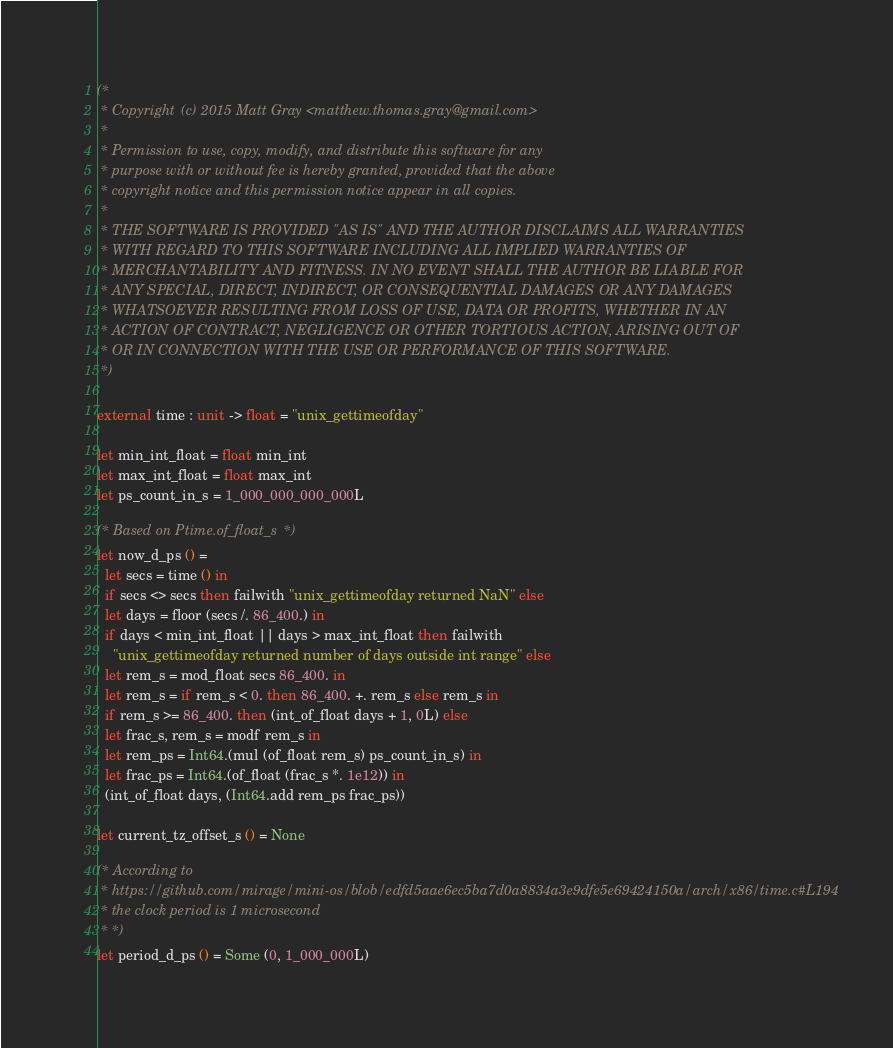<code> <loc_0><loc_0><loc_500><loc_500><_OCaml_>(*
 * Copyright (c) 2015 Matt Gray <matthew.thomas.gray@gmail.com>
 *
 * Permission to use, copy, modify, and distribute this software for any
 * purpose with or without fee is hereby granted, provided that the above
 * copyright notice and this permission notice appear in all copies.
 *
 * THE SOFTWARE IS PROVIDED "AS IS" AND THE AUTHOR DISCLAIMS ALL WARRANTIES
 * WITH REGARD TO THIS SOFTWARE INCLUDING ALL IMPLIED WARRANTIES OF
 * MERCHANTABILITY AND FITNESS. IN NO EVENT SHALL THE AUTHOR BE LIABLE FOR
 * ANY SPECIAL, DIRECT, INDIRECT, OR CONSEQUENTIAL DAMAGES OR ANY DAMAGES
 * WHATSOEVER RESULTING FROM LOSS OF USE, DATA OR PROFITS, WHETHER IN AN
 * ACTION OF CONTRACT, NEGLIGENCE OR OTHER TORTIOUS ACTION, ARISING OUT OF
 * OR IN CONNECTION WITH THE USE OR PERFORMANCE OF THIS SOFTWARE.
 *)

external time : unit -> float = "unix_gettimeofday"

let min_int_float = float min_int
let max_int_float = float max_int
let ps_count_in_s = 1_000_000_000_000L

(* Based on Ptime.of_float_s *)
let now_d_ps () =
  let secs = time () in
  if secs <> secs then failwith "unix_gettimeofday returned NaN" else
  let days = floor (secs /. 86_400.) in
  if days < min_int_float || days > max_int_float then failwith
    "unix_gettimeofday returned number of days outside int range" else
  let rem_s = mod_float secs 86_400. in
  let rem_s = if rem_s < 0. then 86_400. +. rem_s else rem_s in
  if rem_s >= 86_400. then (int_of_float days + 1, 0L) else
  let frac_s, rem_s = modf rem_s in
  let rem_ps = Int64.(mul (of_float rem_s) ps_count_in_s) in
  let frac_ps = Int64.(of_float (frac_s *. 1e12)) in
  (int_of_float days, (Int64.add rem_ps frac_ps))

let current_tz_offset_s () = None

(* According to
 * https://github.com/mirage/mini-os/blob/edfd5aae6ec5ba7d0a8834a3e9dfe5e69424150a/arch/x86/time.c#L194
 * the clock period is 1 microsecond
 * *)
let period_d_ps () = Some (0, 1_000_000L)
</code> 